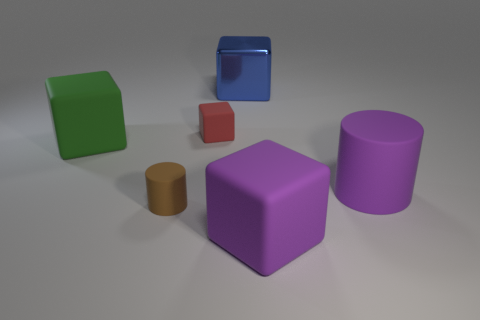There is a cylinder that is on the right side of the red rubber cube; does it have the same color as the small matte cylinder? no 